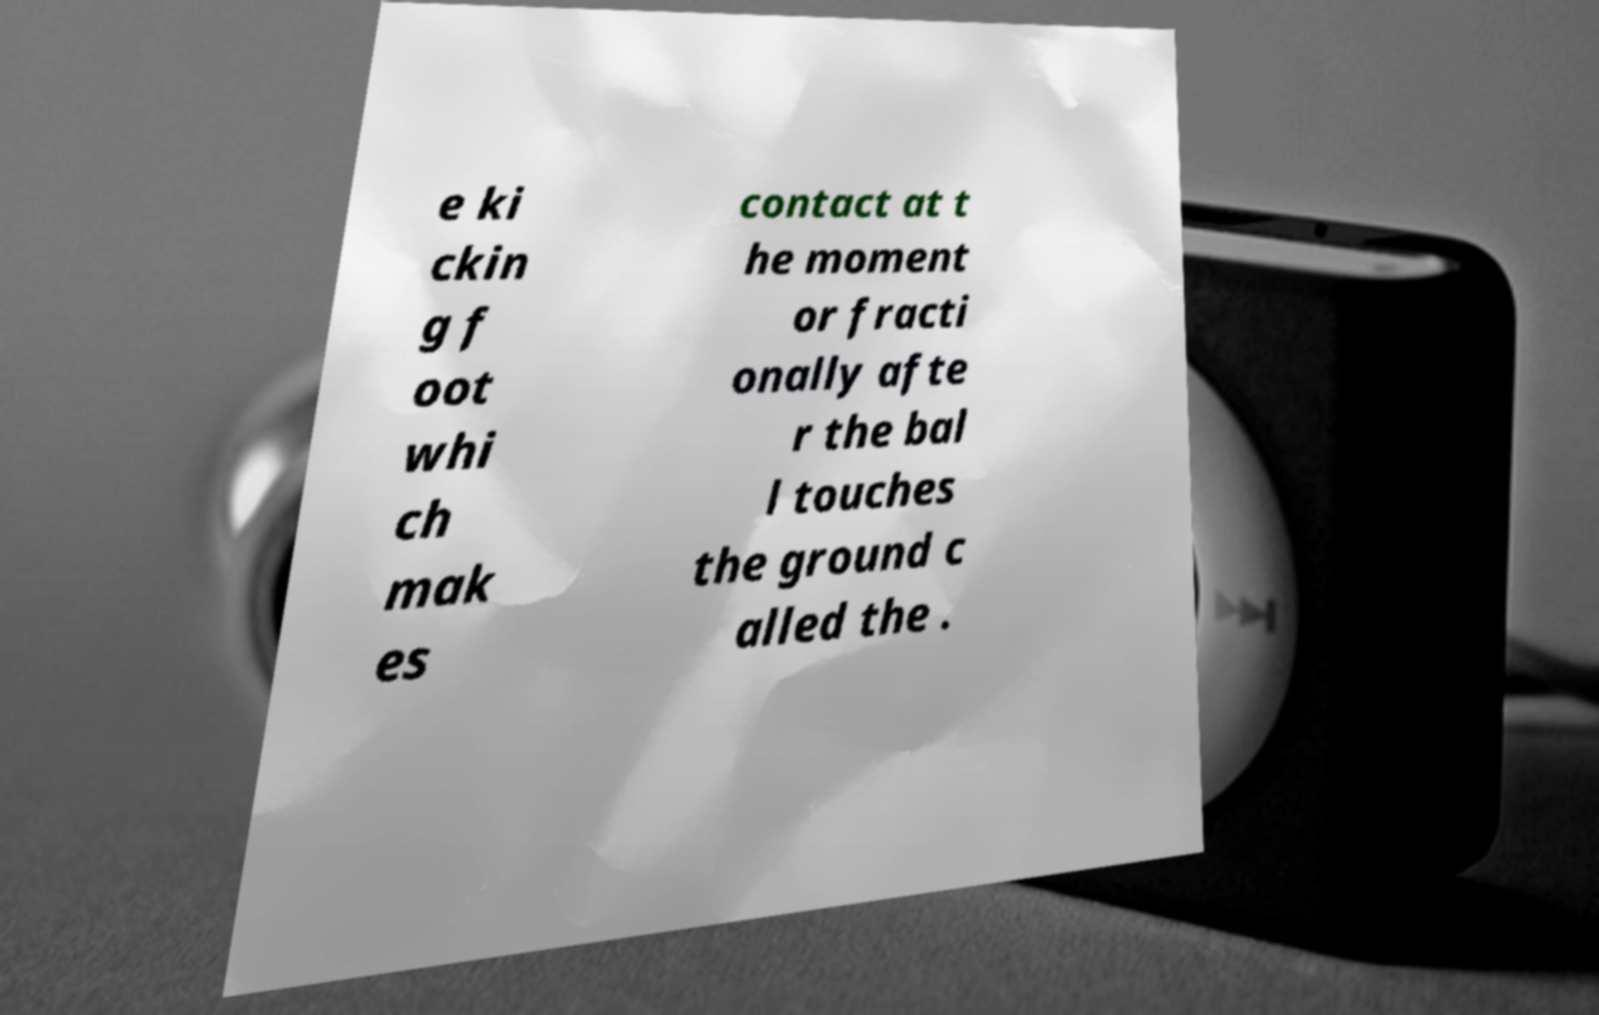Could you assist in decoding the text presented in this image and type it out clearly? e ki ckin g f oot whi ch mak es contact at t he moment or fracti onally afte r the bal l touches the ground c alled the . 